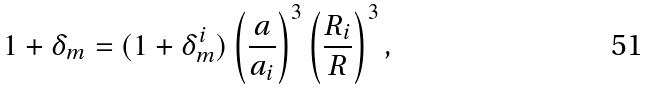<formula> <loc_0><loc_0><loc_500><loc_500>1 + \delta _ { m } = ( 1 + \delta _ { m } ^ { i } ) \left ( \frac { a } { a _ { i } } \right ) ^ { 3 } \left ( \frac { R _ { i } } { R } \right ) ^ { 3 } ,</formula> 